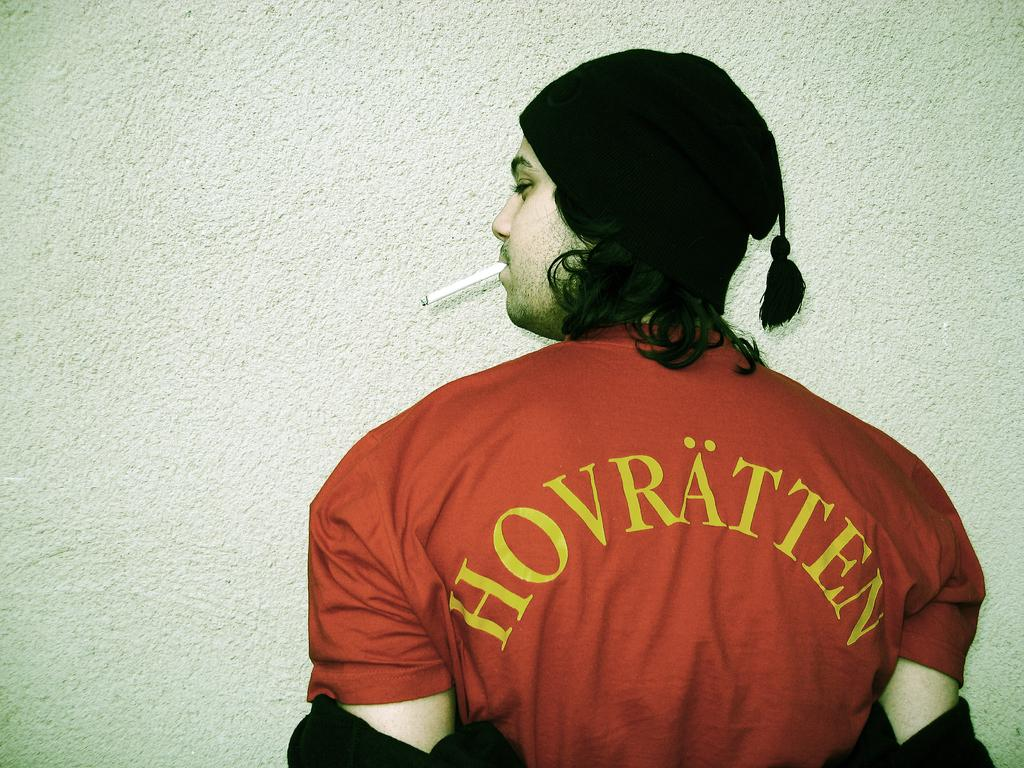Provide a one-sentence caption for the provided image. A man standing with his back to the camera and a shirt reading hovratten. 